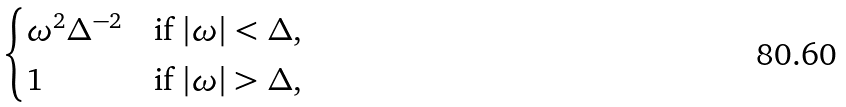<formula> <loc_0><loc_0><loc_500><loc_500>\begin{cases} \omega ^ { 2 } \Delta ^ { - 2 } & \text {if $|\omega| < \Delta$} , \\ 1 & \text {if $|\omega| > \Delta$} , \end{cases}</formula> 